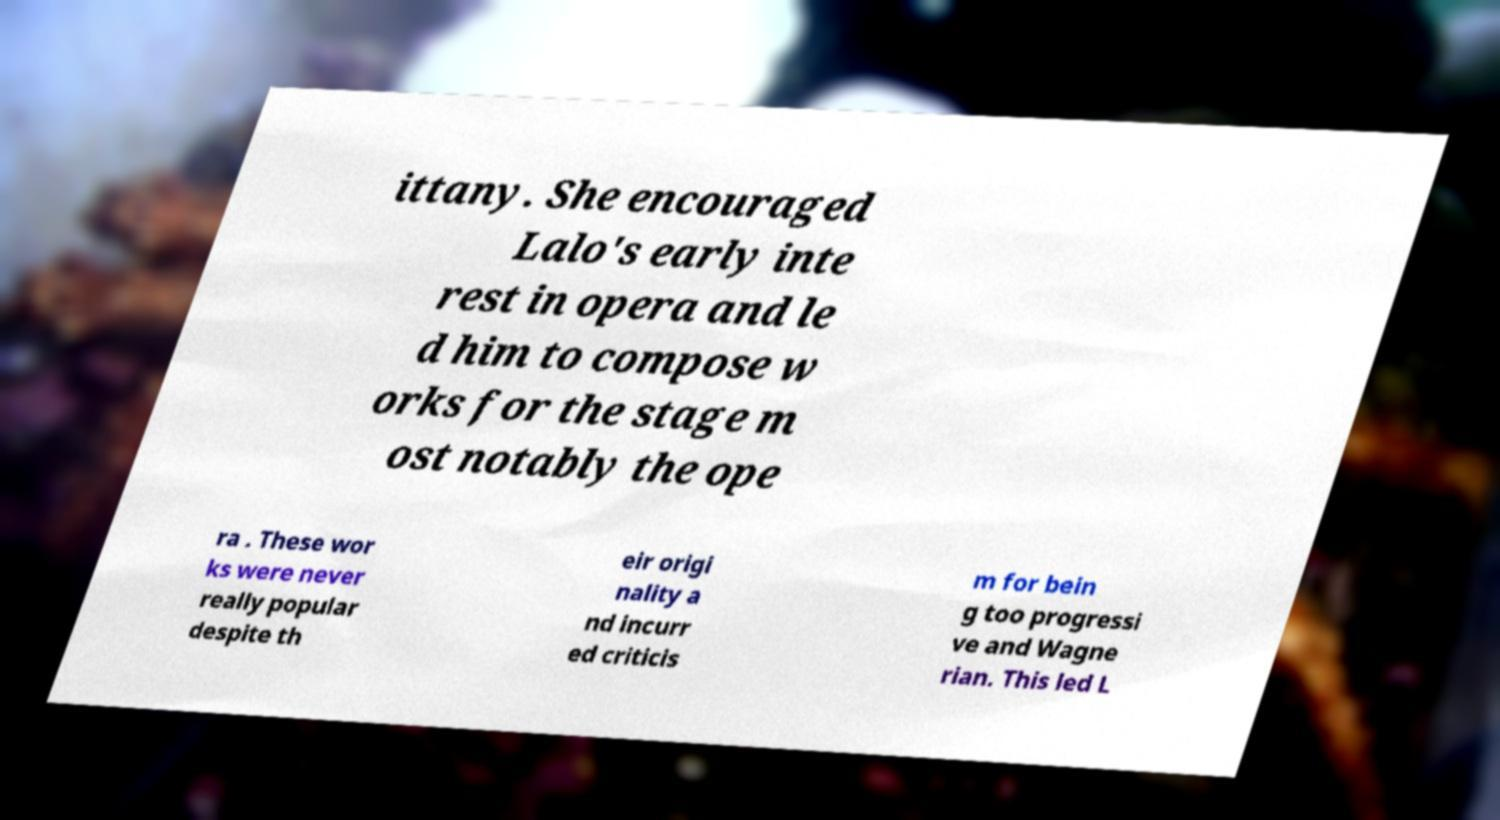Can you read and provide the text displayed in the image?This photo seems to have some interesting text. Can you extract and type it out for me? ittany. She encouraged Lalo's early inte rest in opera and le d him to compose w orks for the stage m ost notably the ope ra . These wor ks were never really popular despite th eir origi nality a nd incurr ed criticis m for bein g too progressi ve and Wagne rian. This led L 